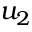Convert formula to latex. <formula><loc_0><loc_0><loc_500><loc_500>u _ { 2 }</formula> 